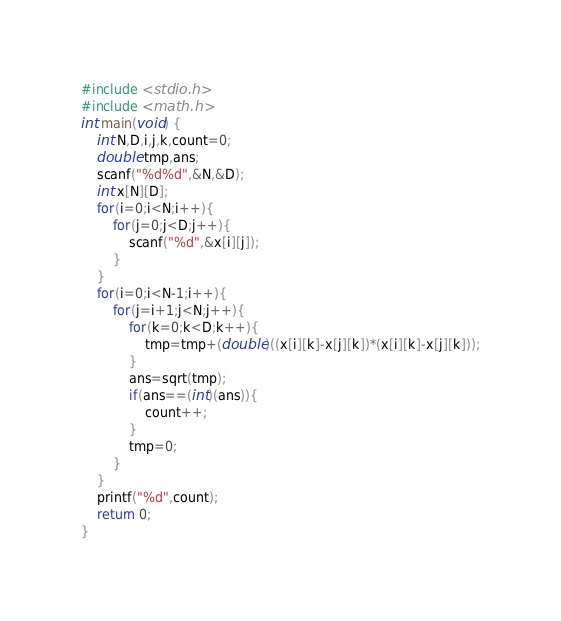Convert code to text. <code><loc_0><loc_0><loc_500><loc_500><_C_>#include <stdio.h>
#include <math.h>
int main(void) {
	int N,D,i,j,k,count=0;
	double tmp,ans;
	scanf("%d%d",&N,&D);
	int x[N][D];
	for(i=0;i<N;i++){
		for(j=0;j<D;j++){
			scanf("%d",&x[i][j]);
		}
	}
	for(i=0;i<N-1;i++){
		for(j=i+1;j<N;j++){
			for(k=0;k<D;k++){
				tmp=tmp+(double)((x[i][k]-x[j][k])*(x[i][k]-x[j][k]));
			}
			ans=sqrt(tmp);
			if(ans==(int)(ans)){
				count++;
			}
			tmp=0;
		}
	}
	printf("%d",count);
	return 0;
}</code> 